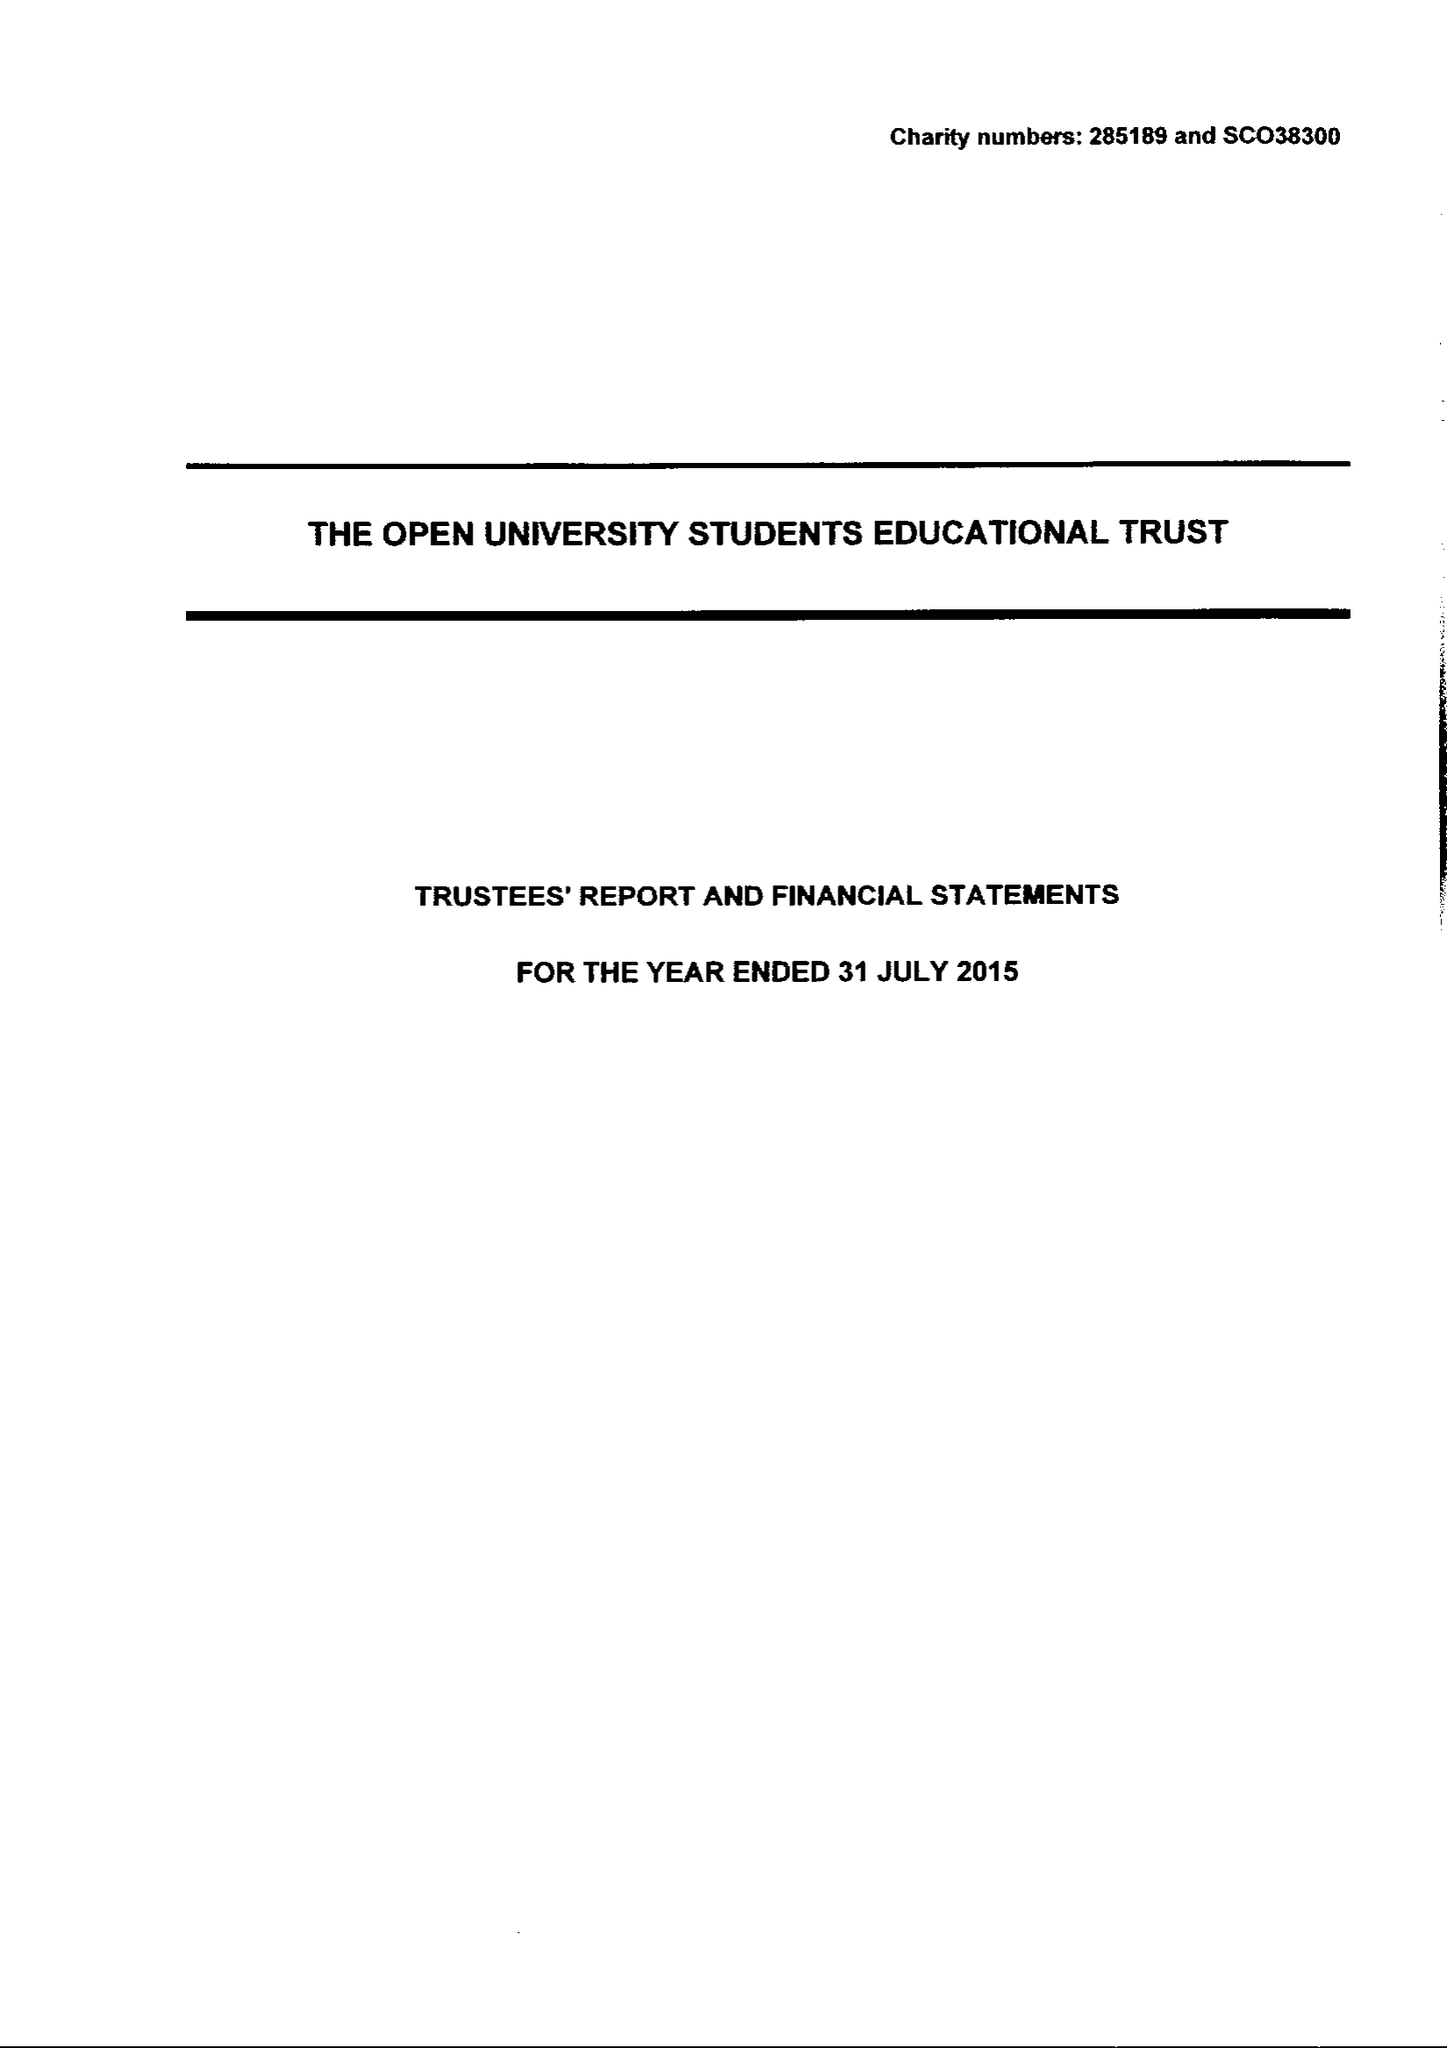What is the value for the income_annually_in_british_pounds?
Answer the question using a single word or phrase. 725929.00 